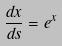Convert formula to latex. <formula><loc_0><loc_0><loc_500><loc_500>\frac { d x } { d s } = e ^ { x }</formula> 